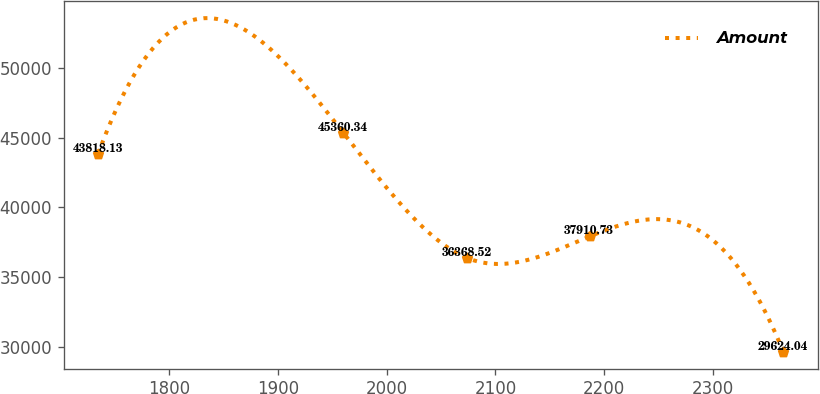<chart> <loc_0><loc_0><loc_500><loc_500><line_chart><ecel><fcel>Amount<nl><fcel>1734.57<fcel>43818.1<nl><fcel>1960<fcel>45360.3<nl><fcel>2073.84<fcel>36368.5<nl><fcel>2186.67<fcel>37910.7<nl><fcel>2364.83<fcel>29624<nl></chart> 